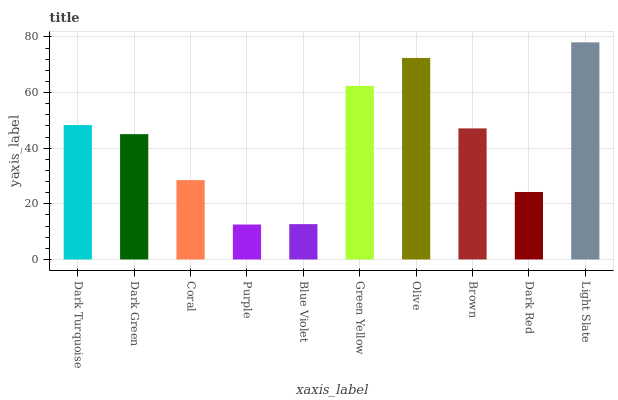Is Purple the minimum?
Answer yes or no. Yes. Is Light Slate the maximum?
Answer yes or no. Yes. Is Dark Green the minimum?
Answer yes or no. No. Is Dark Green the maximum?
Answer yes or no. No. Is Dark Turquoise greater than Dark Green?
Answer yes or no. Yes. Is Dark Green less than Dark Turquoise?
Answer yes or no. Yes. Is Dark Green greater than Dark Turquoise?
Answer yes or no. No. Is Dark Turquoise less than Dark Green?
Answer yes or no. No. Is Brown the high median?
Answer yes or no. Yes. Is Dark Green the low median?
Answer yes or no. Yes. Is Dark Red the high median?
Answer yes or no. No. Is Blue Violet the low median?
Answer yes or no. No. 